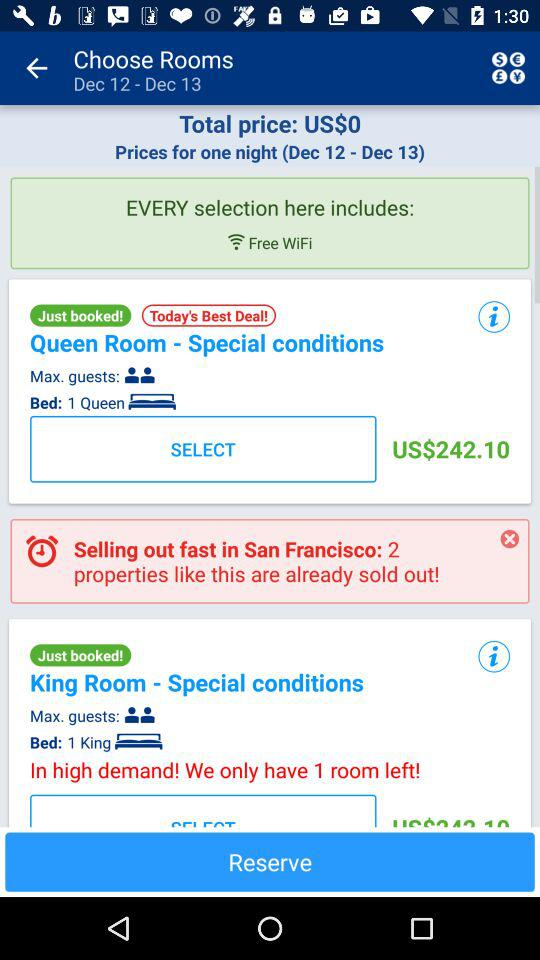What is the maximum number of guests in the queen room? The maximum number of guests in the queen room is 2. 